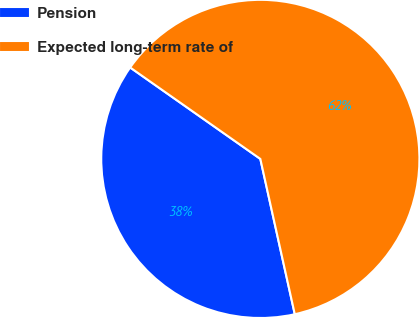Convert chart to OTSL. <chart><loc_0><loc_0><loc_500><loc_500><pie_chart><fcel>Pension<fcel>Expected long-term rate of<nl><fcel>38.22%<fcel>61.78%<nl></chart> 